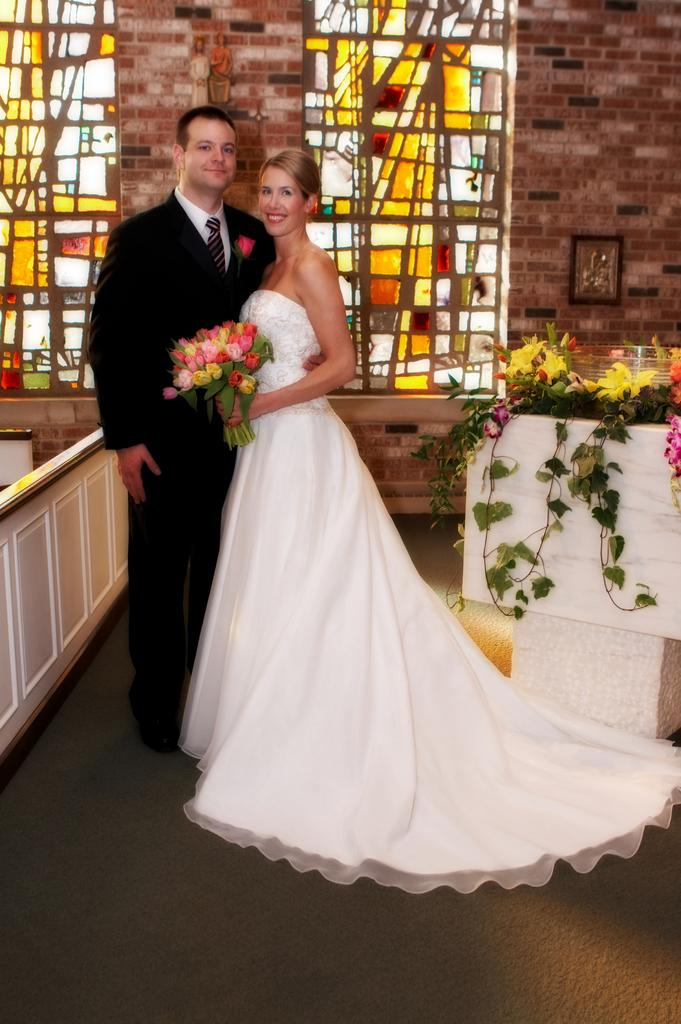How many people are in the image? There are two persons standing in the image. What is the facial expression of the persons? The persons are smiling. What can be seen in the background of the image? There is a wall in the background of the image. What features are present on the wall? There are windows and frames on the wall. Can you tell me how many horses are visible in the image? There are no horses present in the image. What type of nail is being used by the persons in the image? There is no nail being used by the persons in the image. 